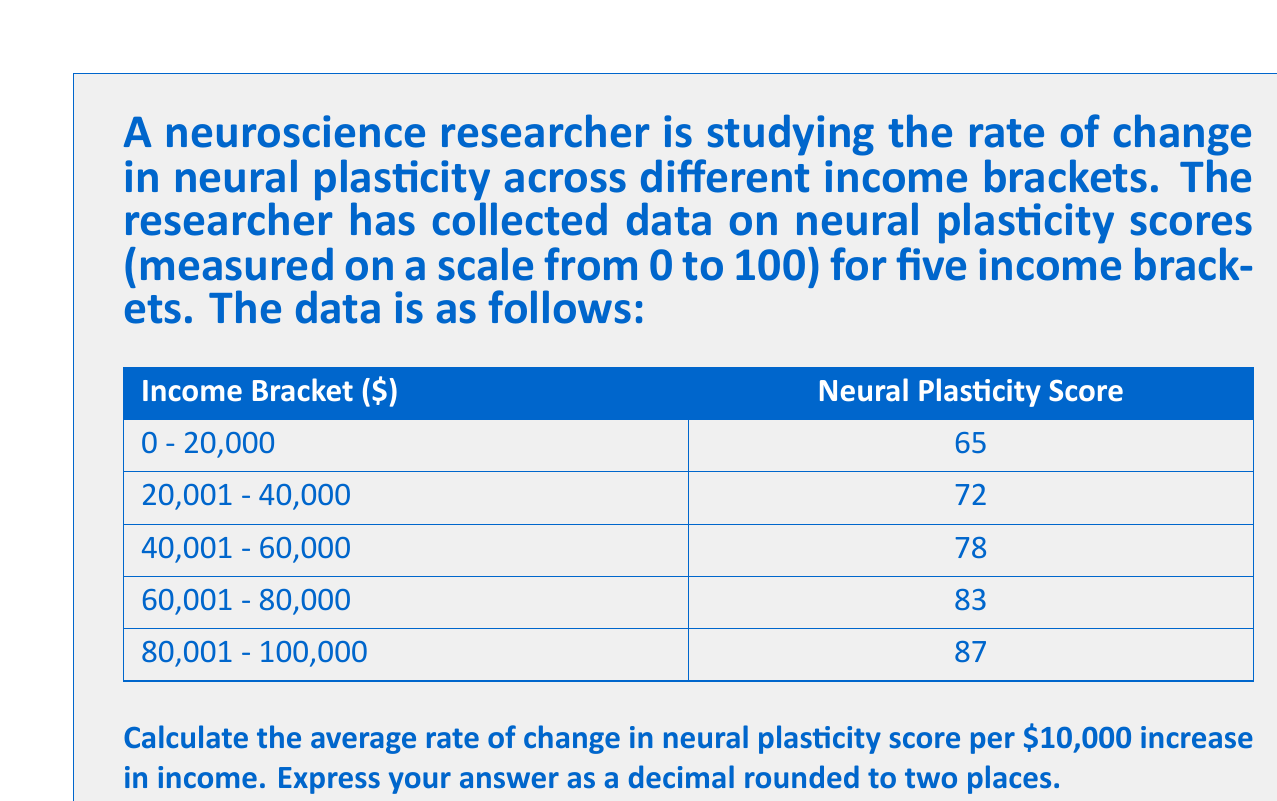Help me with this question. To solve this problem, we need to follow these steps:

1. Calculate the total change in neural plasticity score:
   $\Delta y = 87 - 65 = 22$

2. Calculate the total change in income:
   $\Delta x = 100,000 - 0 = 100,000$

3. Calculate the rate of change using the slope formula:
   $m = \frac{\Delta y}{\Delta x} = \frac{22}{100,000}$

4. Convert this to the rate of change per $10,000:
   $\text{Rate per } 10,000 = \frac{22}{100,000} \times 10,000 = \frac{22}{10} = 2.2$

Therefore, the average rate of change in neural plasticity score is 2.2 points per $10,000 increase in income.

This can be represented mathematically as:

$$\text{Rate of Change} = \frac{\Delta \text{Neural Plasticity Score}}{\Delta \text{Income}} \times 10,000$$

$$= \frac{87 - 65}{100,000 - 0} \times 10,000 = \frac{22}{100,000} \times 10,000 = 2.2$$
Answer: 2.20 